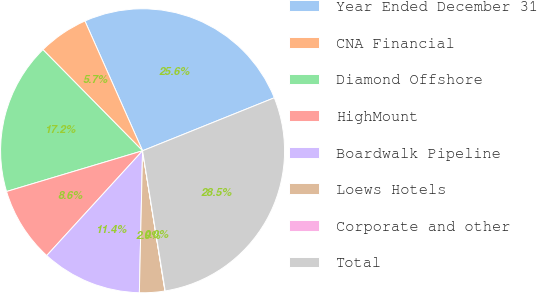Convert chart to OTSL. <chart><loc_0><loc_0><loc_500><loc_500><pie_chart><fcel>Year Ended December 31<fcel>CNA Financial<fcel>Diamond Offshore<fcel>HighMount<fcel>Boardwalk Pipeline<fcel>Loews Hotels<fcel>Corporate and other<fcel>Total<nl><fcel>25.57%<fcel>5.73%<fcel>17.25%<fcel>8.58%<fcel>11.43%<fcel>2.88%<fcel>0.03%<fcel>28.54%<nl></chart> 